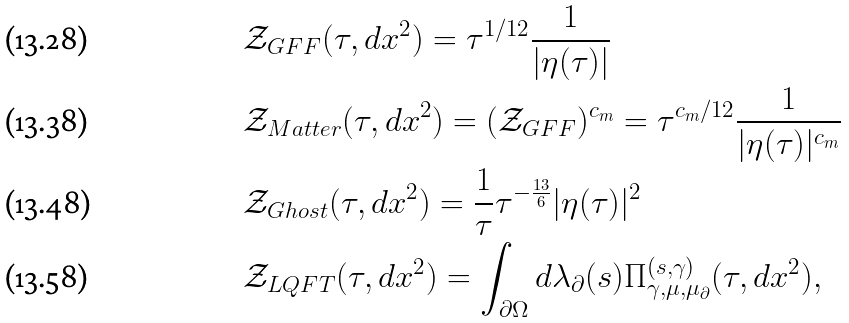<formula> <loc_0><loc_0><loc_500><loc_500>& \mathcal { Z } _ { G F F } ( \tau , d x ^ { 2 } ) = \tau ^ { 1 / 1 2 } \frac { 1 } { | \eta ( \tau ) | } \\ & \mathcal { Z } _ { M a t t e r } ( \tau , d x ^ { 2 } ) = ( \mathcal { Z } _ { G F F } ) ^ { c _ { m } } = \tau ^ { c _ { m } / 1 2 } \frac { 1 } { | \eta ( \tau ) | ^ { c _ { m } } } \\ & \mathcal { Z } _ { G h o s t } ( \tau , d x ^ { 2 } ) = \frac { 1 } { \tau } \tau ^ { - \frac { 1 3 } { 6 } } | \eta ( \tau ) | ^ { 2 } \\ & \mathcal { Z } _ { L Q F T } ( \tau , d x ^ { 2 } ) = \int _ { \partial \Omega } d \lambda _ { \partial } ( s ) \Pi ^ { ( s , \gamma ) } _ { \gamma , \mu , \mu _ { \partial } } ( \tau , d x ^ { 2 } ) ,</formula> 